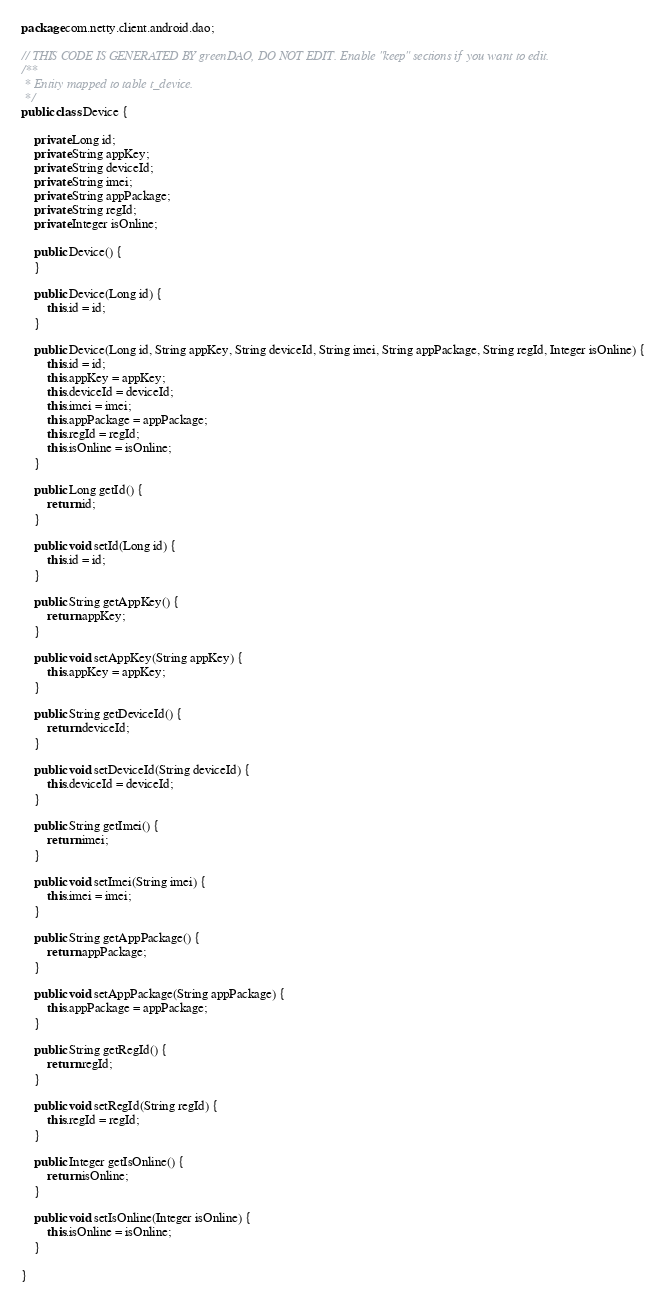<code> <loc_0><loc_0><loc_500><loc_500><_Java_>package com.netty.client.android.dao;

// THIS CODE IS GENERATED BY greenDAO, DO NOT EDIT. Enable "keep" sections if you want to edit. 
/**
 * Entity mapped to table t_device.
 */
public class Device {

    private Long id;
    private String appKey;
    private String deviceId;
    private String imei;
    private String appPackage;
    private String regId;
    private Integer isOnline;

    public Device() {
    }

    public Device(Long id) {
        this.id = id;
    }

    public Device(Long id, String appKey, String deviceId, String imei, String appPackage, String regId, Integer isOnline) {
        this.id = id;
        this.appKey = appKey;
        this.deviceId = deviceId;
        this.imei = imei;
        this.appPackage = appPackage;
        this.regId = regId;
        this.isOnline = isOnline;
    }

    public Long getId() {
        return id;
    }

    public void setId(Long id) {
        this.id = id;
    }

    public String getAppKey() {
        return appKey;
    }

    public void setAppKey(String appKey) {
        this.appKey = appKey;
    }

    public String getDeviceId() {
        return deviceId;
    }

    public void setDeviceId(String deviceId) {
        this.deviceId = deviceId;
    }

    public String getImei() {
        return imei;
    }

    public void setImei(String imei) {
        this.imei = imei;
    }

    public String getAppPackage() {
        return appPackage;
    }

    public void setAppPackage(String appPackage) {
        this.appPackage = appPackage;
    }

    public String getRegId() {
        return regId;
    }

    public void setRegId(String regId) {
        this.regId = regId;
    }

    public Integer getIsOnline() {
        return isOnline;
    }

    public void setIsOnline(Integer isOnline) {
        this.isOnline = isOnline;
    }

}
</code> 